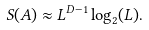<formula> <loc_0><loc_0><loc_500><loc_500>S ( A ) \approx L ^ { D - 1 } \log _ { 2 } ( L ) .</formula> 